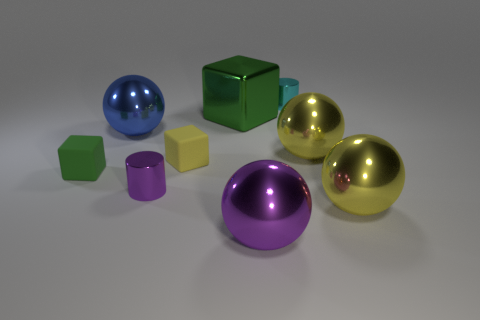There is a metal object behind the green thing right of the yellow thing to the left of the green shiny thing; how big is it?
Ensure brevity in your answer.  Small. Do the small cyan metal object and the small thing left of the tiny purple object have the same shape?
Give a very brief answer. No. Are there any big metal objects of the same color as the large cube?
Offer a very short reply. No. What number of cylinders are either tiny things or metallic things?
Provide a succinct answer. 2. Are there any large green objects that have the same shape as the big purple shiny thing?
Make the answer very short. No. What number of other things are the same color as the big cube?
Make the answer very short. 1. Is the number of small yellow objects on the right side of the small cyan metallic object less than the number of large yellow rubber objects?
Give a very brief answer. No. What number of purple matte cylinders are there?
Your answer should be compact. 0. How many small things are made of the same material as the purple ball?
Provide a succinct answer. 2. How many objects are green objects behind the green matte cube or large yellow metallic things?
Keep it short and to the point. 3. 